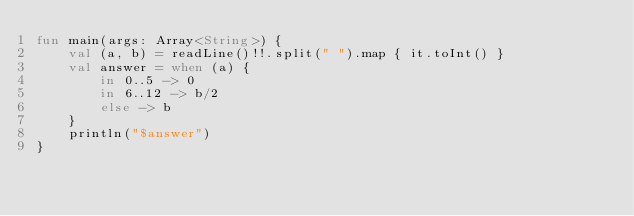<code> <loc_0><loc_0><loc_500><loc_500><_Kotlin_>fun main(args: Array<String>) {
    val (a, b) = readLine()!!.split(" ").map { it.toInt() }
    val answer = when (a) {
        in 0..5 -> 0
        in 6..12 -> b/2
        else -> b
    }
    println("$answer")
}</code> 